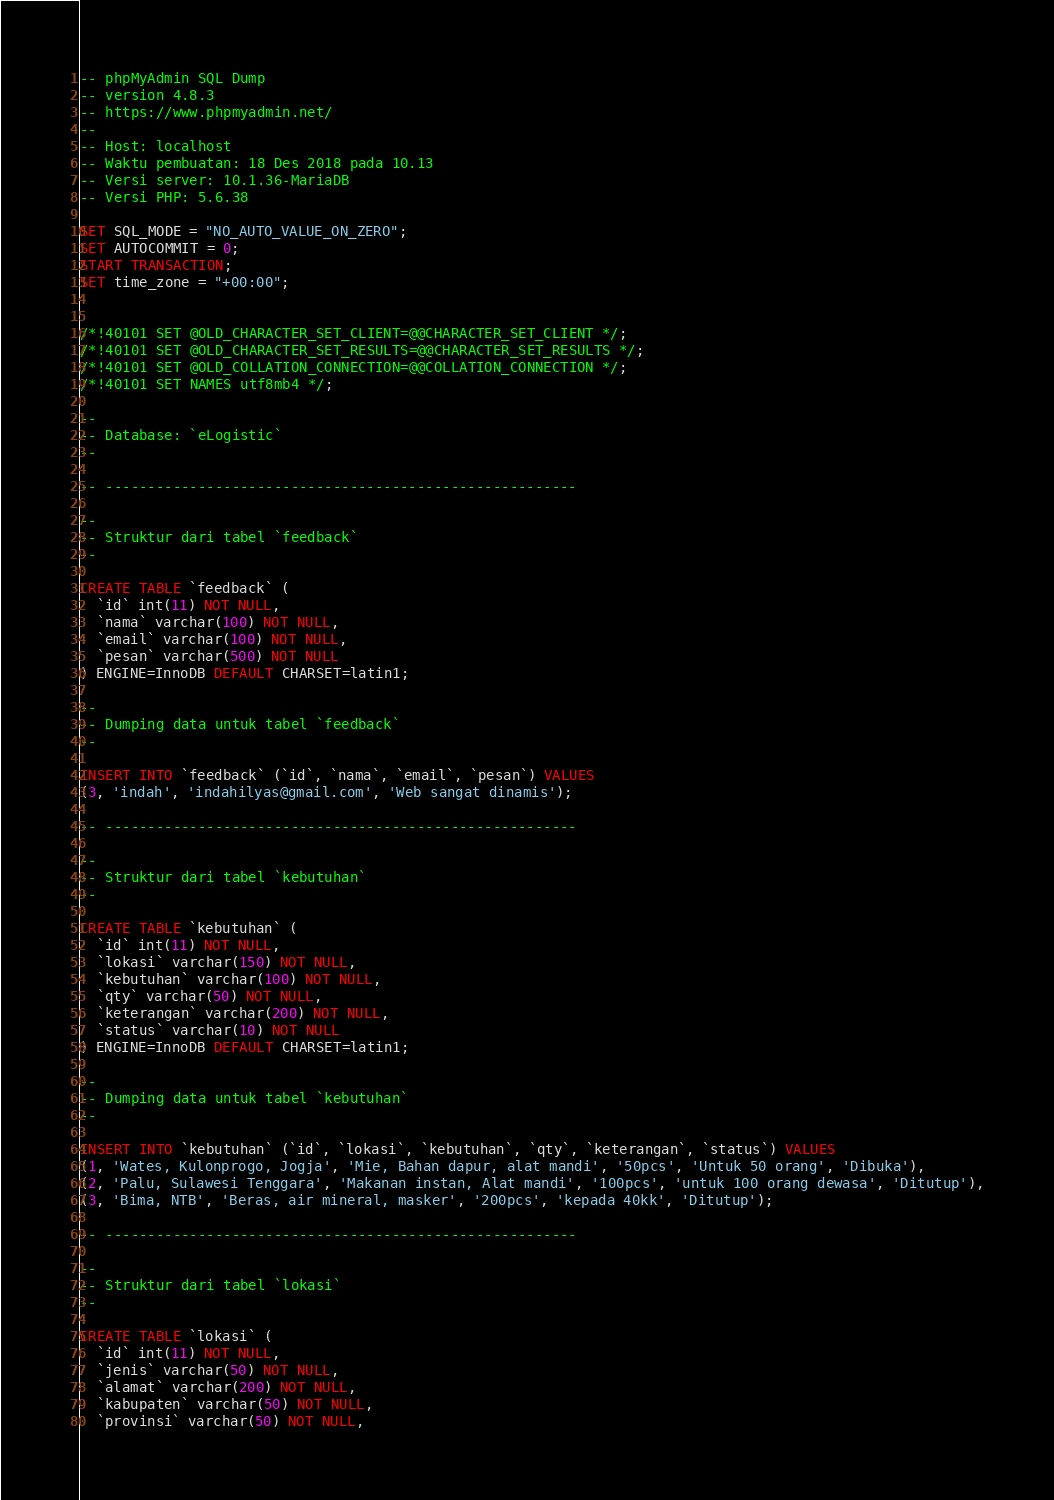Convert code to text. <code><loc_0><loc_0><loc_500><loc_500><_SQL_>-- phpMyAdmin SQL Dump
-- version 4.8.3
-- https://www.phpmyadmin.net/
--
-- Host: localhost
-- Waktu pembuatan: 18 Des 2018 pada 10.13
-- Versi server: 10.1.36-MariaDB
-- Versi PHP: 5.6.38

SET SQL_MODE = "NO_AUTO_VALUE_ON_ZERO";
SET AUTOCOMMIT = 0;
START TRANSACTION;
SET time_zone = "+00:00";


/*!40101 SET @OLD_CHARACTER_SET_CLIENT=@@CHARACTER_SET_CLIENT */;
/*!40101 SET @OLD_CHARACTER_SET_RESULTS=@@CHARACTER_SET_RESULTS */;
/*!40101 SET @OLD_COLLATION_CONNECTION=@@COLLATION_CONNECTION */;
/*!40101 SET NAMES utf8mb4 */;

--
-- Database: `eLogistic`
--

-- --------------------------------------------------------

--
-- Struktur dari tabel `feedback`
--

CREATE TABLE `feedback` (
  `id` int(11) NOT NULL,
  `nama` varchar(100) NOT NULL,
  `email` varchar(100) NOT NULL,
  `pesan` varchar(500) NOT NULL
) ENGINE=InnoDB DEFAULT CHARSET=latin1;

--
-- Dumping data untuk tabel `feedback`
--

INSERT INTO `feedback` (`id`, `nama`, `email`, `pesan`) VALUES
(3, 'indah', 'indahilyas@gmail.com', 'Web sangat dinamis');

-- --------------------------------------------------------

--
-- Struktur dari tabel `kebutuhan`
--

CREATE TABLE `kebutuhan` (
  `id` int(11) NOT NULL,
  `lokasi` varchar(150) NOT NULL,
  `kebutuhan` varchar(100) NOT NULL,
  `qty` varchar(50) NOT NULL,
  `keterangan` varchar(200) NOT NULL,
  `status` varchar(10) NOT NULL
) ENGINE=InnoDB DEFAULT CHARSET=latin1;

--
-- Dumping data untuk tabel `kebutuhan`
--

INSERT INTO `kebutuhan` (`id`, `lokasi`, `kebutuhan`, `qty`, `keterangan`, `status`) VALUES
(1, 'Wates, Kulonprogo, Jogja', 'Mie, Bahan dapur, alat mandi', '50pcs', 'Untuk 50 orang', 'Dibuka'),
(2, 'Palu, Sulawesi Tenggara', 'Makanan instan, Alat mandi', '100pcs', 'untuk 100 orang dewasa', 'Ditutup'),
(3, 'Bima, NTB', 'Beras, air mineral, masker', '200pcs', 'kepada 40kk', 'Ditutup');

-- --------------------------------------------------------

--
-- Struktur dari tabel `lokasi`
--

CREATE TABLE `lokasi` (
  `id` int(11) NOT NULL,
  `jenis` varchar(50) NOT NULL,
  `alamat` varchar(200) NOT NULL,
  `kabupaten` varchar(50) NOT NULL,
  `provinsi` varchar(50) NOT NULL,</code> 